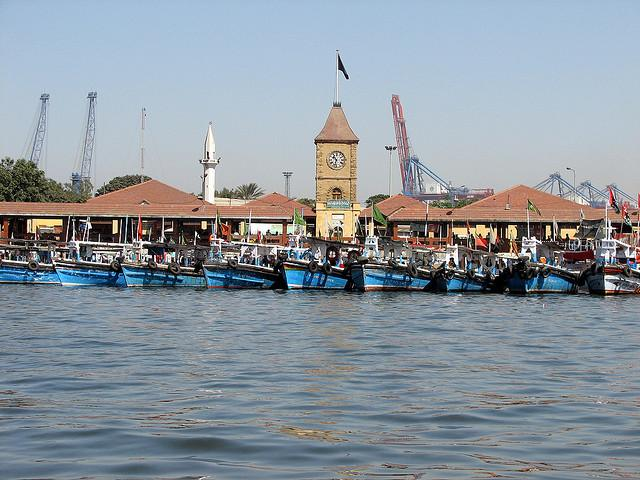What except for a flag are the highest emanations coming from here? cranes 